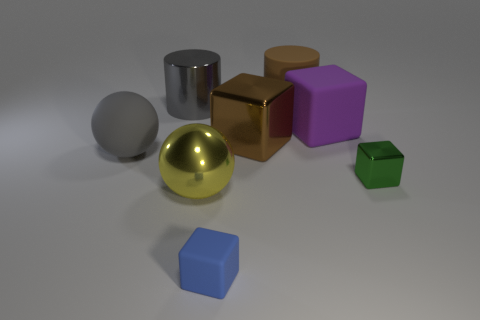Is there any other thing that is the same shape as the big purple matte thing?
Keep it short and to the point. Yes. Do the metallic cylinder and the big ball behind the green metallic cube have the same color?
Keep it short and to the point. Yes. What is the shape of the object on the left side of the metallic cylinder?
Keep it short and to the point. Sphere. How many other things are the same material as the green cube?
Your response must be concise. 3. What is the material of the big brown cylinder?
Ensure brevity in your answer.  Rubber. What number of large objects are either rubber things or cubes?
Keep it short and to the point. 4. There is a metal cylinder; how many big yellow things are behind it?
Provide a succinct answer. 0. Are there any things that have the same color as the large matte cylinder?
Your answer should be very brief. Yes. What is the shape of the gray metallic object that is the same size as the brown rubber cylinder?
Your response must be concise. Cylinder. What number of brown things are large blocks or big shiny spheres?
Ensure brevity in your answer.  1. 